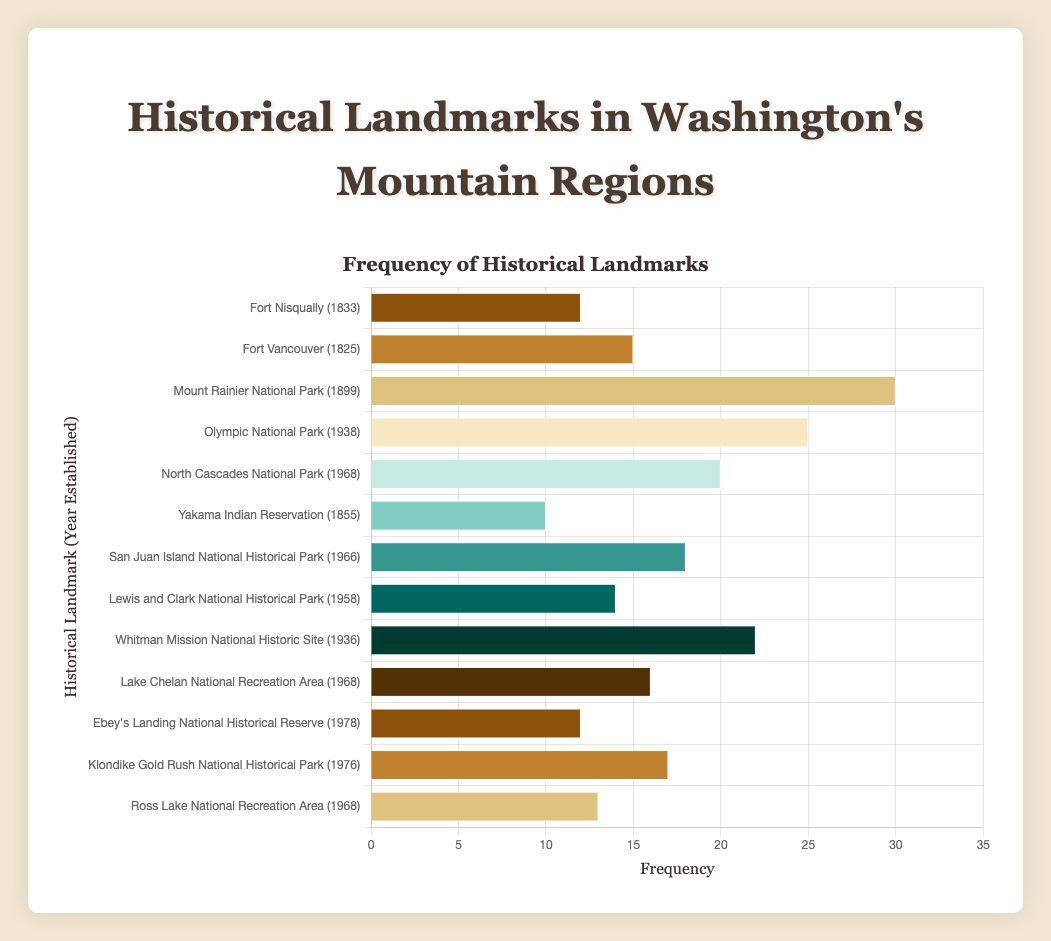Which historical landmark has the highest frequency? The landmark with the longest bar in the chart has the highest frequency. "Mount Rainier National Park" has the longest bar, indicating the highest frequency.
Answer: Mount Rainier National Park How many landmarks have a frequency greater than 20? Count the number of bars that extend past the 20 mark on the x-axis. The bars for "Mount Rainier National Park", "Olympic National Park", and "Whitman Mission National Historic Site" surpass 20.
Answer: 3 Which landmark, established before 1900, has the lowest frequency? Identify landmarks established before 1900 and compare their frequencies. "Fort Nisqually" (1833) has 12 and "Fort Vancouver" (1825) has 15. "Fort Nisqually" has the lower frequency.
Answer: Fort Nisqually What is the difference in frequency between "Klondike Gold Rush National Historical Park" and "Ebey's Landing National Historical Reserve"? Subtract the frequency of "Ebey's Landing National Historical Reserve" (12) from "Klondike Gold Rush National Historical Park" (17). 17 - 12 = 5
Answer: 5 Find the median frequency of all the landmarks. List the frequencies: 10, 12, 12, 13, 14, 15, 16, 17, 18, 20, 22, 25, 30. The middle value (7th in this ordered set) is 16.
Answer: 16 Which landmark established after 1950 has the highest frequency? Compare the frequencies of landmarks established after 1950. "North Cascades National Park" has the highest frequency at 20.
Answer: North Cascades National Park How many landmarks were established in the 1960s? Identify landmarks with establishment years in the 1960s: "San Juan Island National Historical Park" (1966), "North Cascades National Park" (1968), "Lake Chelan National Recreation Area" (1968), and "Ross Lake National Recreation Area" (1968). There are 4 landmarks.
Answer: 4 What's the total frequency of all landmarks established before 1900? Sum the frequencies of landmarks established before 1900: "Fort Nisqually" (12), "Fort Vancouver" (15), "Mount Rainier National Park" (30), and "Yakama Indian Reservation" (10). 12 + 15 + 30 + 10 = 67
Answer: 67 